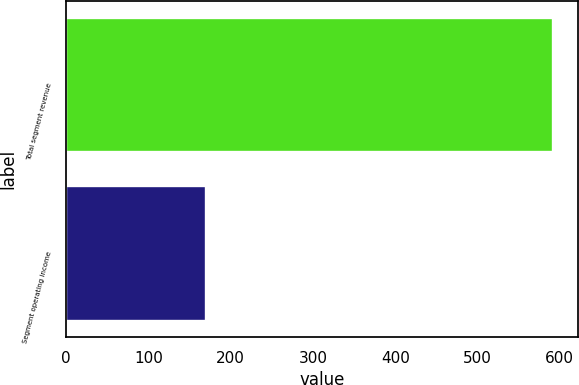Convert chart to OTSL. <chart><loc_0><loc_0><loc_500><loc_500><bar_chart><fcel>Total segment revenue<fcel>Segment operating income<nl><fcel>592<fcel>170<nl></chart> 